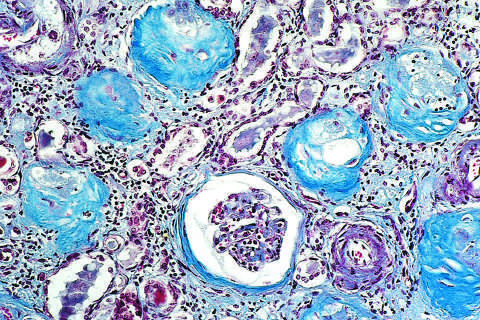does there show complete replacement of virtually all glomeruli by blue-staining collagen?
Answer the question using a single word or phrase. No 